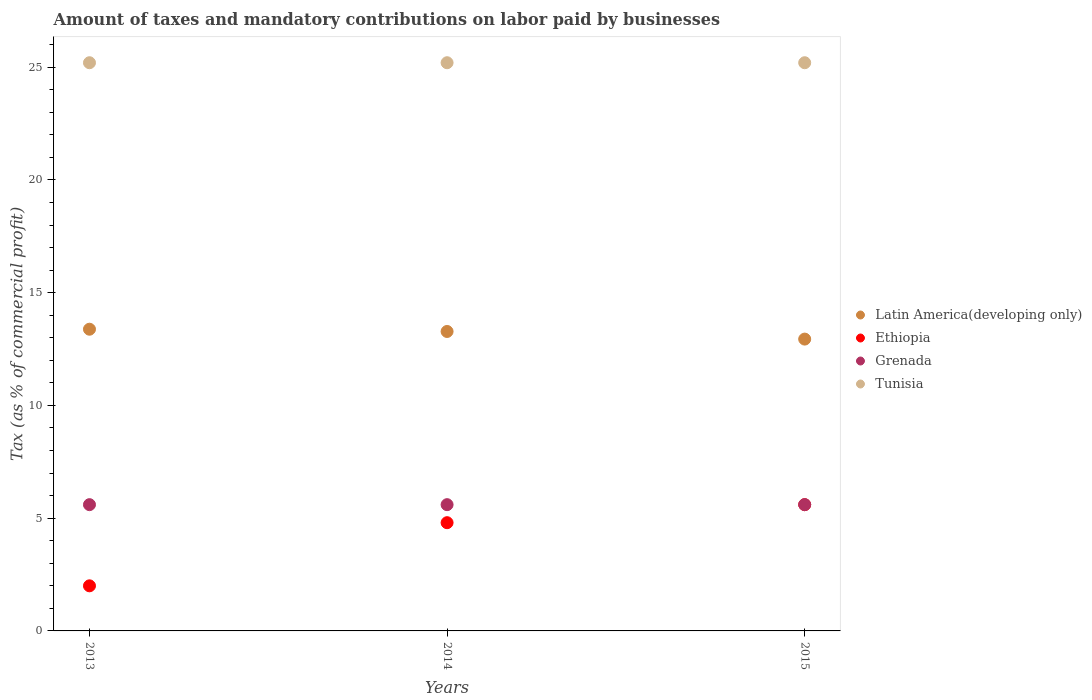How many different coloured dotlines are there?
Ensure brevity in your answer.  4. What is the percentage of taxes paid by businesses in Latin America(developing only) in 2015?
Make the answer very short. 12.94. Across all years, what is the maximum percentage of taxes paid by businesses in Ethiopia?
Your answer should be very brief. 5.6. Across all years, what is the minimum percentage of taxes paid by businesses in Tunisia?
Give a very brief answer. 25.2. In which year was the percentage of taxes paid by businesses in Tunisia maximum?
Give a very brief answer. 2013. What is the total percentage of taxes paid by businesses in Latin America(developing only) in the graph?
Offer a very short reply. 39.6. What is the difference between the percentage of taxes paid by businesses in Ethiopia in 2015 and the percentage of taxes paid by businesses in Tunisia in 2013?
Your answer should be compact. -19.6. What is the average percentage of taxes paid by businesses in Ethiopia per year?
Your response must be concise. 4.13. In the year 2015, what is the difference between the percentage of taxes paid by businesses in Ethiopia and percentage of taxes paid by businesses in Tunisia?
Offer a terse response. -19.6. What is the ratio of the percentage of taxes paid by businesses in Latin America(developing only) in 2013 to that in 2014?
Offer a terse response. 1.01. Is the percentage of taxes paid by businesses in Ethiopia in 2013 less than that in 2014?
Offer a very short reply. Yes. In how many years, is the percentage of taxes paid by businesses in Latin America(developing only) greater than the average percentage of taxes paid by businesses in Latin America(developing only) taken over all years?
Offer a very short reply. 2. Is the sum of the percentage of taxes paid by businesses in Ethiopia in 2014 and 2015 greater than the maximum percentage of taxes paid by businesses in Grenada across all years?
Make the answer very short. Yes. Is it the case that in every year, the sum of the percentage of taxes paid by businesses in Grenada and percentage of taxes paid by businesses in Latin America(developing only)  is greater than the sum of percentage of taxes paid by businesses in Tunisia and percentage of taxes paid by businesses in Ethiopia?
Your answer should be very brief. No. Is it the case that in every year, the sum of the percentage of taxes paid by businesses in Tunisia and percentage of taxes paid by businesses in Latin America(developing only)  is greater than the percentage of taxes paid by businesses in Grenada?
Your response must be concise. Yes. Does the percentage of taxes paid by businesses in Grenada monotonically increase over the years?
Give a very brief answer. No. How are the legend labels stacked?
Make the answer very short. Vertical. What is the title of the graph?
Keep it short and to the point. Amount of taxes and mandatory contributions on labor paid by businesses. Does "Panama" appear as one of the legend labels in the graph?
Make the answer very short. No. What is the label or title of the Y-axis?
Make the answer very short. Tax (as % of commercial profit). What is the Tax (as % of commercial profit) of Latin America(developing only) in 2013?
Provide a short and direct response. 13.38. What is the Tax (as % of commercial profit) in Tunisia in 2013?
Provide a succinct answer. 25.2. What is the Tax (as % of commercial profit) of Latin America(developing only) in 2014?
Your answer should be compact. 13.28. What is the Tax (as % of commercial profit) in Ethiopia in 2014?
Your answer should be very brief. 4.8. What is the Tax (as % of commercial profit) of Tunisia in 2014?
Provide a succinct answer. 25.2. What is the Tax (as % of commercial profit) in Latin America(developing only) in 2015?
Ensure brevity in your answer.  12.94. What is the Tax (as % of commercial profit) of Tunisia in 2015?
Make the answer very short. 25.2. Across all years, what is the maximum Tax (as % of commercial profit) in Latin America(developing only)?
Offer a very short reply. 13.38. Across all years, what is the maximum Tax (as % of commercial profit) of Tunisia?
Your response must be concise. 25.2. Across all years, what is the minimum Tax (as % of commercial profit) of Latin America(developing only)?
Offer a terse response. 12.94. Across all years, what is the minimum Tax (as % of commercial profit) in Ethiopia?
Your answer should be very brief. 2. Across all years, what is the minimum Tax (as % of commercial profit) of Tunisia?
Offer a very short reply. 25.2. What is the total Tax (as % of commercial profit) of Latin America(developing only) in the graph?
Provide a succinct answer. 39.6. What is the total Tax (as % of commercial profit) in Ethiopia in the graph?
Ensure brevity in your answer.  12.4. What is the total Tax (as % of commercial profit) of Tunisia in the graph?
Make the answer very short. 75.6. What is the difference between the Tax (as % of commercial profit) of Tunisia in 2013 and that in 2014?
Offer a terse response. 0. What is the difference between the Tax (as % of commercial profit) of Latin America(developing only) in 2013 and that in 2015?
Offer a terse response. 0.44. What is the difference between the Tax (as % of commercial profit) in Ethiopia in 2013 and that in 2015?
Your response must be concise. -3.6. What is the difference between the Tax (as % of commercial profit) in Tunisia in 2013 and that in 2015?
Give a very brief answer. 0. What is the difference between the Tax (as % of commercial profit) in Latin America(developing only) in 2014 and that in 2015?
Keep it short and to the point. 0.34. What is the difference between the Tax (as % of commercial profit) in Ethiopia in 2014 and that in 2015?
Provide a succinct answer. -0.8. What is the difference between the Tax (as % of commercial profit) in Grenada in 2014 and that in 2015?
Provide a succinct answer. 0. What is the difference between the Tax (as % of commercial profit) of Tunisia in 2014 and that in 2015?
Ensure brevity in your answer.  0. What is the difference between the Tax (as % of commercial profit) of Latin America(developing only) in 2013 and the Tax (as % of commercial profit) of Ethiopia in 2014?
Keep it short and to the point. 8.58. What is the difference between the Tax (as % of commercial profit) in Latin America(developing only) in 2013 and the Tax (as % of commercial profit) in Grenada in 2014?
Offer a terse response. 7.78. What is the difference between the Tax (as % of commercial profit) of Latin America(developing only) in 2013 and the Tax (as % of commercial profit) of Tunisia in 2014?
Provide a succinct answer. -11.82. What is the difference between the Tax (as % of commercial profit) of Ethiopia in 2013 and the Tax (as % of commercial profit) of Grenada in 2014?
Provide a succinct answer. -3.6. What is the difference between the Tax (as % of commercial profit) of Ethiopia in 2013 and the Tax (as % of commercial profit) of Tunisia in 2014?
Provide a succinct answer. -23.2. What is the difference between the Tax (as % of commercial profit) in Grenada in 2013 and the Tax (as % of commercial profit) in Tunisia in 2014?
Give a very brief answer. -19.6. What is the difference between the Tax (as % of commercial profit) in Latin America(developing only) in 2013 and the Tax (as % of commercial profit) in Ethiopia in 2015?
Your answer should be very brief. 7.78. What is the difference between the Tax (as % of commercial profit) in Latin America(developing only) in 2013 and the Tax (as % of commercial profit) in Grenada in 2015?
Provide a short and direct response. 7.78. What is the difference between the Tax (as % of commercial profit) in Latin America(developing only) in 2013 and the Tax (as % of commercial profit) in Tunisia in 2015?
Your answer should be compact. -11.82. What is the difference between the Tax (as % of commercial profit) of Ethiopia in 2013 and the Tax (as % of commercial profit) of Tunisia in 2015?
Your answer should be compact. -23.2. What is the difference between the Tax (as % of commercial profit) of Grenada in 2013 and the Tax (as % of commercial profit) of Tunisia in 2015?
Provide a succinct answer. -19.6. What is the difference between the Tax (as % of commercial profit) in Latin America(developing only) in 2014 and the Tax (as % of commercial profit) in Ethiopia in 2015?
Your answer should be very brief. 7.68. What is the difference between the Tax (as % of commercial profit) of Latin America(developing only) in 2014 and the Tax (as % of commercial profit) of Grenada in 2015?
Make the answer very short. 7.68. What is the difference between the Tax (as % of commercial profit) of Latin America(developing only) in 2014 and the Tax (as % of commercial profit) of Tunisia in 2015?
Offer a very short reply. -11.92. What is the difference between the Tax (as % of commercial profit) in Ethiopia in 2014 and the Tax (as % of commercial profit) in Tunisia in 2015?
Provide a short and direct response. -20.4. What is the difference between the Tax (as % of commercial profit) of Grenada in 2014 and the Tax (as % of commercial profit) of Tunisia in 2015?
Offer a very short reply. -19.6. What is the average Tax (as % of commercial profit) in Latin America(developing only) per year?
Keep it short and to the point. 13.2. What is the average Tax (as % of commercial profit) in Ethiopia per year?
Give a very brief answer. 4.13. What is the average Tax (as % of commercial profit) of Tunisia per year?
Give a very brief answer. 25.2. In the year 2013, what is the difference between the Tax (as % of commercial profit) of Latin America(developing only) and Tax (as % of commercial profit) of Ethiopia?
Keep it short and to the point. 11.38. In the year 2013, what is the difference between the Tax (as % of commercial profit) in Latin America(developing only) and Tax (as % of commercial profit) in Grenada?
Provide a short and direct response. 7.78. In the year 2013, what is the difference between the Tax (as % of commercial profit) of Latin America(developing only) and Tax (as % of commercial profit) of Tunisia?
Your answer should be very brief. -11.82. In the year 2013, what is the difference between the Tax (as % of commercial profit) of Ethiopia and Tax (as % of commercial profit) of Grenada?
Provide a succinct answer. -3.6. In the year 2013, what is the difference between the Tax (as % of commercial profit) of Ethiopia and Tax (as % of commercial profit) of Tunisia?
Offer a terse response. -23.2. In the year 2013, what is the difference between the Tax (as % of commercial profit) in Grenada and Tax (as % of commercial profit) in Tunisia?
Your answer should be very brief. -19.6. In the year 2014, what is the difference between the Tax (as % of commercial profit) of Latin America(developing only) and Tax (as % of commercial profit) of Ethiopia?
Give a very brief answer. 8.48. In the year 2014, what is the difference between the Tax (as % of commercial profit) of Latin America(developing only) and Tax (as % of commercial profit) of Grenada?
Make the answer very short. 7.68. In the year 2014, what is the difference between the Tax (as % of commercial profit) in Latin America(developing only) and Tax (as % of commercial profit) in Tunisia?
Provide a short and direct response. -11.92. In the year 2014, what is the difference between the Tax (as % of commercial profit) of Ethiopia and Tax (as % of commercial profit) of Tunisia?
Ensure brevity in your answer.  -20.4. In the year 2014, what is the difference between the Tax (as % of commercial profit) of Grenada and Tax (as % of commercial profit) of Tunisia?
Keep it short and to the point. -19.6. In the year 2015, what is the difference between the Tax (as % of commercial profit) in Latin America(developing only) and Tax (as % of commercial profit) in Ethiopia?
Ensure brevity in your answer.  7.34. In the year 2015, what is the difference between the Tax (as % of commercial profit) in Latin America(developing only) and Tax (as % of commercial profit) in Grenada?
Provide a succinct answer. 7.34. In the year 2015, what is the difference between the Tax (as % of commercial profit) in Latin America(developing only) and Tax (as % of commercial profit) in Tunisia?
Provide a succinct answer. -12.26. In the year 2015, what is the difference between the Tax (as % of commercial profit) of Ethiopia and Tax (as % of commercial profit) of Grenada?
Make the answer very short. 0. In the year 2015, what is the difference between the Tax (as % of commercial profit) of Ethiopia and Tax (as % of commercial profit) of Tunisia?
Ensure brevity in your answer.  -19.6. In the year 2015, what is the difference between the Tax (as % of commercial profit) of Grenada and Tax (as % of commercial profit) of Tunisia?
Offer a terse response. -19.6. What is the ratio of the Tax (as % of commercial profit) in Latin America(developing only) in 2013 to that in 2014?
Provide a succinct answer. 1.01. What is the ratio of the Tax (as % of commercial profit) in Ethiopia in 2013 to that in 2014?
Your response must be concise. 0.42. What is the ratio of the Tax (as % of commercial profit) in Grenada in 2013 to that in 2014?
Provide a succinct answer. 1. What is the ratio of the Tax (as % of commercial profit) of Tunisia in 2013 to that in 2014?
Provide a succinct answer. 1. What is the ratio of the Tax (as % of commercial profit) of Latin America(developing only) in 2013 to that in 2015?
Give a very brief answer. 1.03. What is the ratio of the Tax (as % of commercial profit) in Ethiopia in 2013 to that in 2015?
Ensure brevity in your answer.  0.36. What is the ratio of the Tax (as % of commercial profit) in Tunisia in 2013 to that in 2015?
Offer a terse response. 1. What is the ratio of the Tax (as % of commercial profit) of Latin America(developing only) in 2014 to that in 2015?
Your answer should be very brief. 1.03. What is the ratio of the Tax (as % of commercial profit) of Grenada in 2014 to that in 2015?
Provide a succinct answer. 1. What is the difference between the highest and the second highest Tax (as % of commercial profit) in Grenada?
Your answer should be very brief. 0. What is the difference between the highest and the lowest Tax (as % of commercial profit) in Latin America(developing only)?
Provide a succinct answer. 0.44. What is the difference between the highest and the lowest Tax (as % of commercial profit) of Grenada?
Your answer should be very brief. 0. 